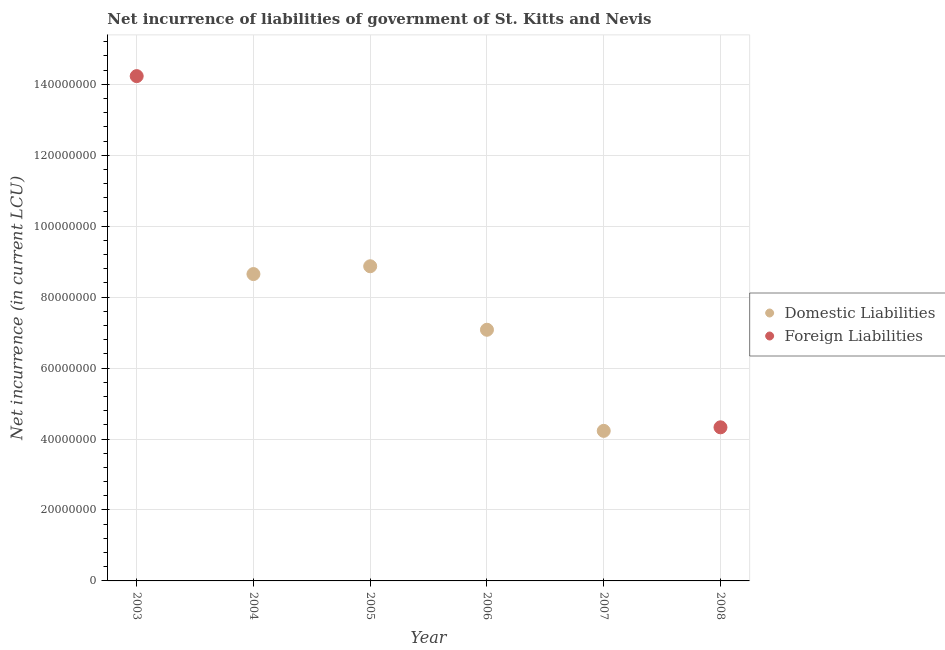Is the number of dotlines equal to the number of legend labels?
Provide a short and direct response. No. What is the net incurrence of foreign liabilities in 2007?
Give a very brief answer. 0. Across all years, what is the maximum net incurrence of domestic liabilities?
Give a very brief answer. 8.87e+07. What is the total net incurrence of foreign liabilities in the graph?
Your answer should be very brief. 1.86e+08. What is the difference between the net incurrence of domestic liabilities in 2004 and that in 2007?
Make the answer very short. 4.42e+07. What is the difference between the net incurrence of domestic liabilities in 2004 and the net incurrence of foreign liabilities in 2008?
Offer a very short reply. 4.32e+07. What is the average net incurrence of domestic liabilities per year?
Offer a very short reply. 4.80e+07. In how many years, is the net incurrence of domestic liabilities greater than 104000000 LCU?
Give a very brief answer. 0. What is the ratio of the net incurrence of domestic liabilities in 2005 to that in 2007?
Make the answer very short. 2.1. Is the net incurrence of domestic liabilities in 2004 less than that in 2006?
Offer a very short reply. No. What is the difference between the highest and the second highest net incurrence of domestic liabilities?
Offer a terse response. 2.20e+06. What is the difference between the highest and the lowest net incurrence of foreign liabilities?
Give a very brief answer. 1.42e+08. In how many years, is the net incurrence of foreign liabilities greater than the average net incurrence of foreign liabilities taken over all years?
Your response must be concise. 2. Does the net incurrence of foreign liabilities monotonically increase over the years?
Your answer should be compact. No. How many years are there in the graph?
Provide a short and direct response. 6. What is the difference between two consecutive major ticks on the Y-axis?
Make the answer very short. 2.00e+07. Where does the legend appear in the graph?
Provide a succinct answer. Center right. What is the title of the graph?
Make the answer very short. Net incurrence of liabilities of government of St. Kitts and Nevis. What is the label or title of the X-axis?
Your answer should be compact. Year. What is the label or title of the Y-axis?
Your response must be concise. Net incurrence (in current LCU). What is the Net incurrence (in current LCU) of Foreign Liabilities in 2003?
Provide a short and direct response. 1.42e+08. What is the Net incurrence (in current LCU) in Domestic Liabilities in 2004?
Give a very brief answer. 8.65e+07. What is the Net incurrence (in current LCU) in Foreign Liabilities in 2004?
Your response must be concise. 0. What is the Net incurrence (in current LCU) in Domestic Liabilities in 2005?
Provide a short and direct response. 8.87e+07. What is the Net incurrence (in current LCU) in Foreign Liabilities in 2005?
Keep it short and to the point. 0. What is the Net incurrence (in current LCU) in Domestic Liabilities in 2006?
Your answer should be very brief. 7.08e+07. What is the Net incurrence (in current LCU) in Foreign Liabilities in 2006?
Provide a succinct answer. 0. What is the Net incurrence (in current LCU) of Domestic Liabilities in 2007?
Offer a terse response. 4.23e+07. What is the Net incurrence (in current LCU) in Foreign Liabilities in 2008?
Offer a very short reply. 4.33e+07. Across all years, what is the maximum Net incurrence (in current LCU) in Domestic Liabilities?
Your response must be concise. 8.87e+07. Across all years, what is the maximum Net incurrence (in current LCU) in Foreign Liabilities?
Your answer should be very brief. 1.42e+08. Across all years, what is the minimum Net incurrence (in current LCU) of Domestic Liabilities?
Give a very brief answer. 0. What is the total Net incurrence (in current LCU) in Domestic Liabilities in the graph?
Offer a terse response. 2.88e+08. What is the total Net incurrence (in current LCU) in Foreign Liabilities in the graph?
Ensure brevity in your answer.  1.86e+08. What is the difference between the Net incurrence (in current LCU) in Foreign Liabilities in 2003 and that in 2008?
Offer a very short reply. 9.90e+07. What is the difference between the Net incurrence (in current LCU) in Domestic Liabilities in 2004 and that in 2005?
Give a very brief answer. -2.20e+06. What is the difference between the Net incurrence (in current LCU) in Domestic Liabilities in 2004 and that in 2006?
Ensure brevity in your answer.  1.57e+07. What is the difference between the Net incurrence (in current LCU) in Domestic Liabilities in 2004 and that in 2007?
Your answer should be compact. 4.42e+07. What is the difference between the Net incurrence (in current LCU) of Domestic Liabilities in 2005 and that in 2006?
Make the answer very short. 1.79e+07. What is the difference between the Net incurrence (in current LCU) in Domestic Liabilities in 2005 and that in 2007?
Your answer should be very brief. 4.64e+07. What is the difference between the Net incurrence (in current LCU) of Domestic Liabilities in 2006 and that in 2007?
Provide a succinct answer. 2.85e+07. What is the difference between the Net incurrence (in current LCU) of Domestic Liabilities in 2004 and the Net incurrence (in current LCU) of Foreign Liabilities in 2008?
Your answer should be very brief. 4.32e+07. What is the difference between the Net incurrence (in current LCU) of Domestic Liabilities in 2005 and the Net incurrence (in current LCU) of Foreign Liabilities in 2008?
Your answer should be very brief. 4.54e+07. What is the difference between the Net incurrence (in current LCU) in Domestic Liabilities in 2006 and the Net incurrence (in current LCU) in Foreign Liabilities in 2008?
Provide a succinct answer. 2.75e+07. What is the average Net incurrence (in current LCU) of Domestic Liabilities per year?
Your answer should be very brief. 4.80e+07. What is the average Net incurrence (in current LCU) in Foreign Liabilities per year?
Provide a short and direct response. 3.09e+07. What is the ratio of the Net incurrence (in current LCU) of Foreign Liabilities in 2003 to that in 2008?
Provide a short and direct response. 3.29. What is the ratio of the Net incurrence (in current LCU) of Domestic Liabilities in 2004 to that in 2005?
Provide a short and direct response. 0.98. What is the ratio of the Net incurrence (in current LCU) in Domestic Liabilities in 2004 to that in 2006?
Make the answer very short. 1.22. What is the ratio of the Net incurrence (in current LCU) of Domestic Liabilities in 2004 to that in 2007?
Your answer should be very brief. 2.04. What is the ratio of the Net incurrence (in current LCU) of Domestic Liabilities in 2005 to that in 2006?
Your answer should be compact. 1.25. What is the ratio of the Net incurrence (in current LCU) of Domestic Liabilities in 2005 to that in 2007?
Offer a very short reply. 2.1. What is the ratio of the Net incurrence (in current LCU) of Domestic Liabilities in 2006 to that in 2007?
Provide a succinct answer. 1.67. What is the difference between the highest and the second highest Net incurrence (in current LCU) in Domestic Liabilities?
Offer a terse response. 2.20e+06. What is the difference between the highest and the lowest Net incurrence (in current LCU) in Domestic Liabilities?
Keep it short and to the point. 8.87e+07. What is the difference between the highest and the lowest Net incurrence (in current LCU) in Foreign Liabilities?
Provide a succinct answer. 1.42e+08. 